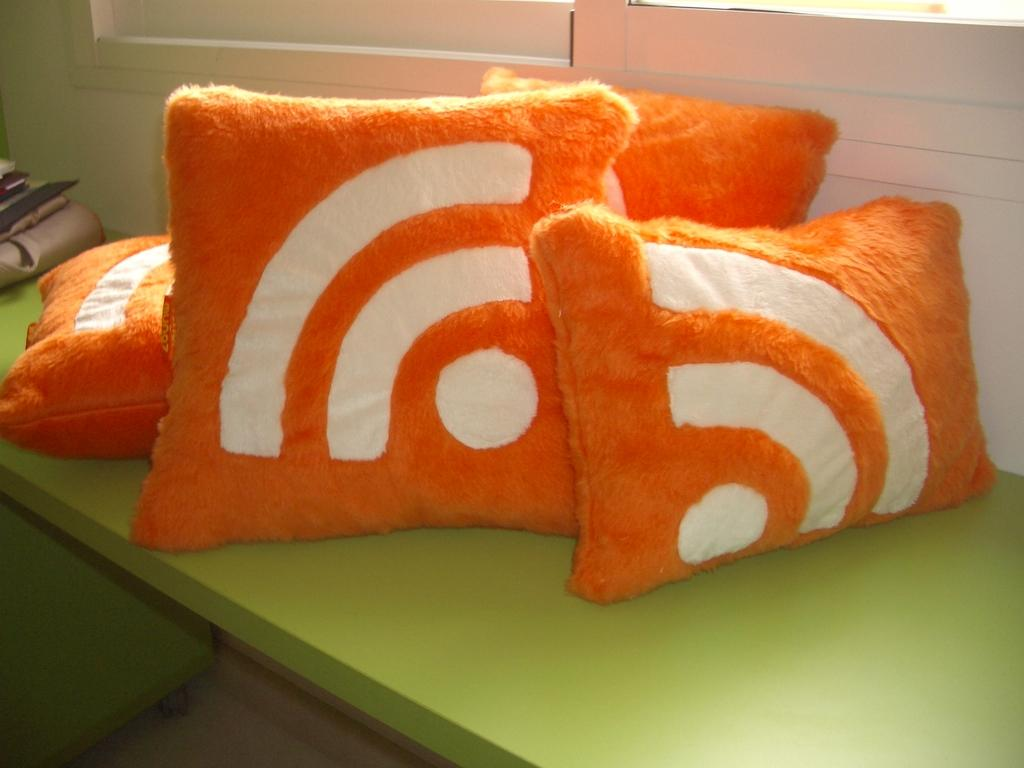What objects are on the table in the image? There are cushions and a bag on the table in the image. Can you describe the background of the image? There is a wall in the background of the image. What type of story is the rat telling in the image? There is no rat or story present in the image. What type of prose is written on the wall in the image? There is no prose or writing on the wall in the image. 